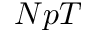Convert formula to latex. <formula><loc_0><loc_0><loc_500><loc_500>N p T</formula> 